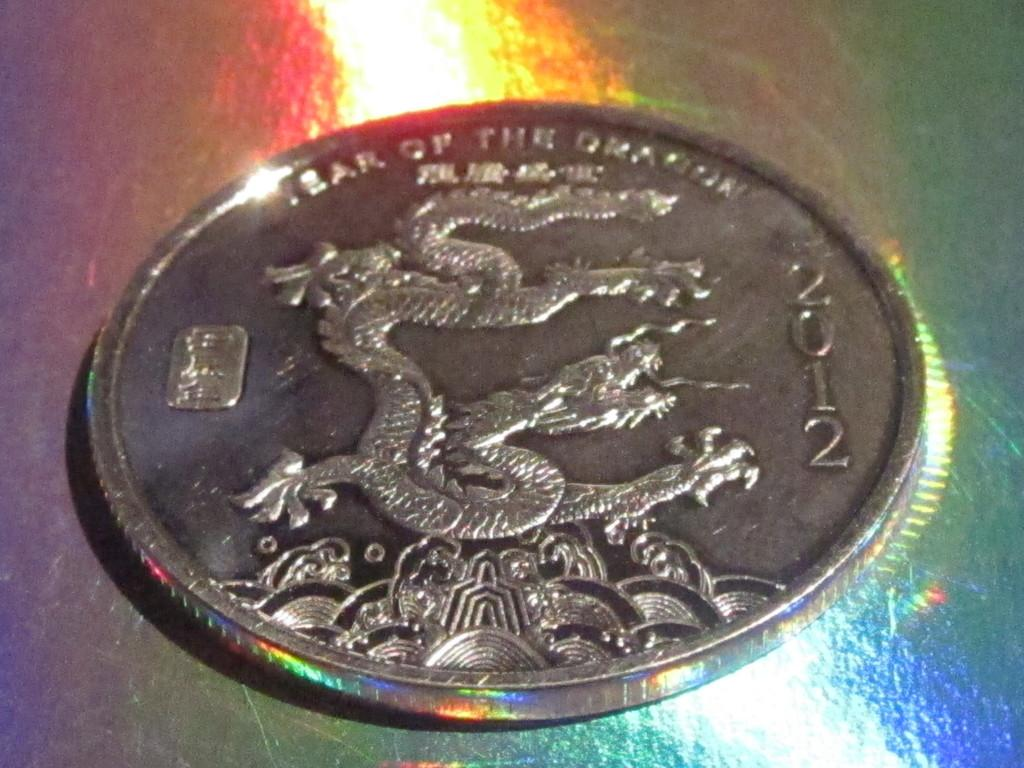<image>
Relay a brief, clear account of the picture shown. A 2012 coin that celebrates the year of the dragon. 